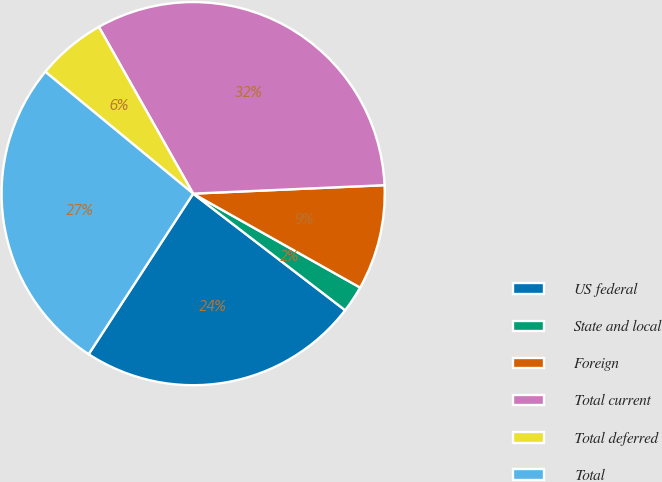Convert chart. <chart><loc_0><loc_0><loc_500><loc_500><pie_chart><fcel>US federal<fcel>State and local<fcel>Foreign<fcel>Total current<fcel>Total deferred<fcel>Total<nl><fcel>23.77%<fcel>2.26%<fcel>8.86%<fcel>32.49%<fcel>5.84%<fcel>26.79%<nl></chart> 